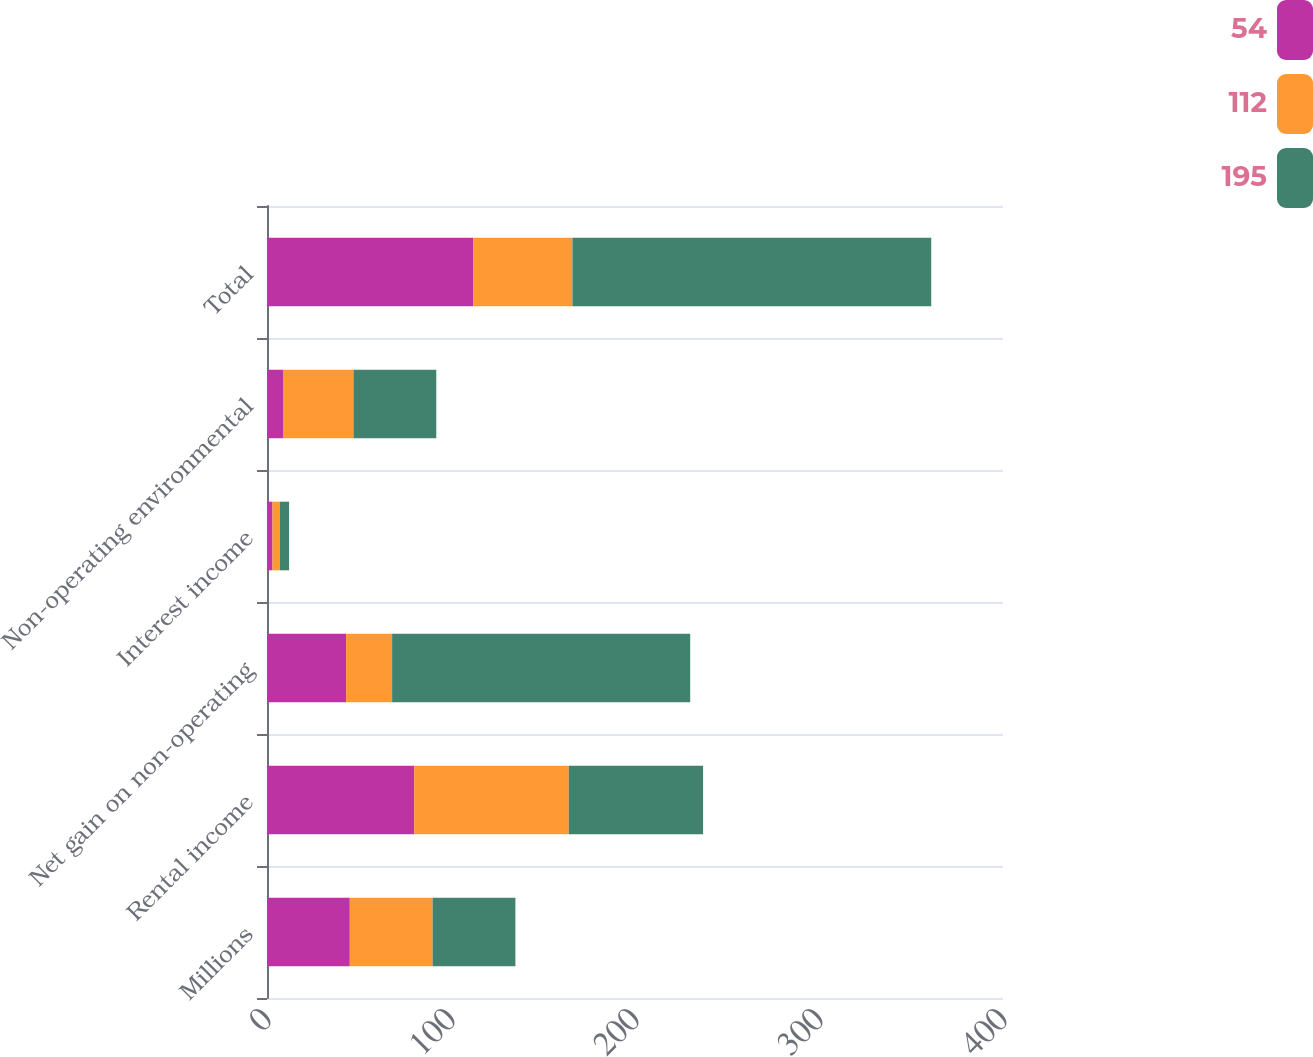<chart> <loc_0><loc_0><loc_500><loc_500><stacked_bar_chart><ecel><fcel>Millions<fcel>Rental income<fcel>Net gain on non-operating<fcel>Interest income<fcel>Non-operating environmental<fcel>Total<nl><fcel>54<fcel>45<fcel>80<fcel>43<fcel>3<fcel>9<fcel>112<nl><fcel>112<fcel>45<fcel>84<fcel>25<fcel>4<fcel>38<fcel>54<nl><fcel>195<fcel>45<fcel>73<fcel>162<fcel>5<fcel>45<fcel>195<nl></chart> 